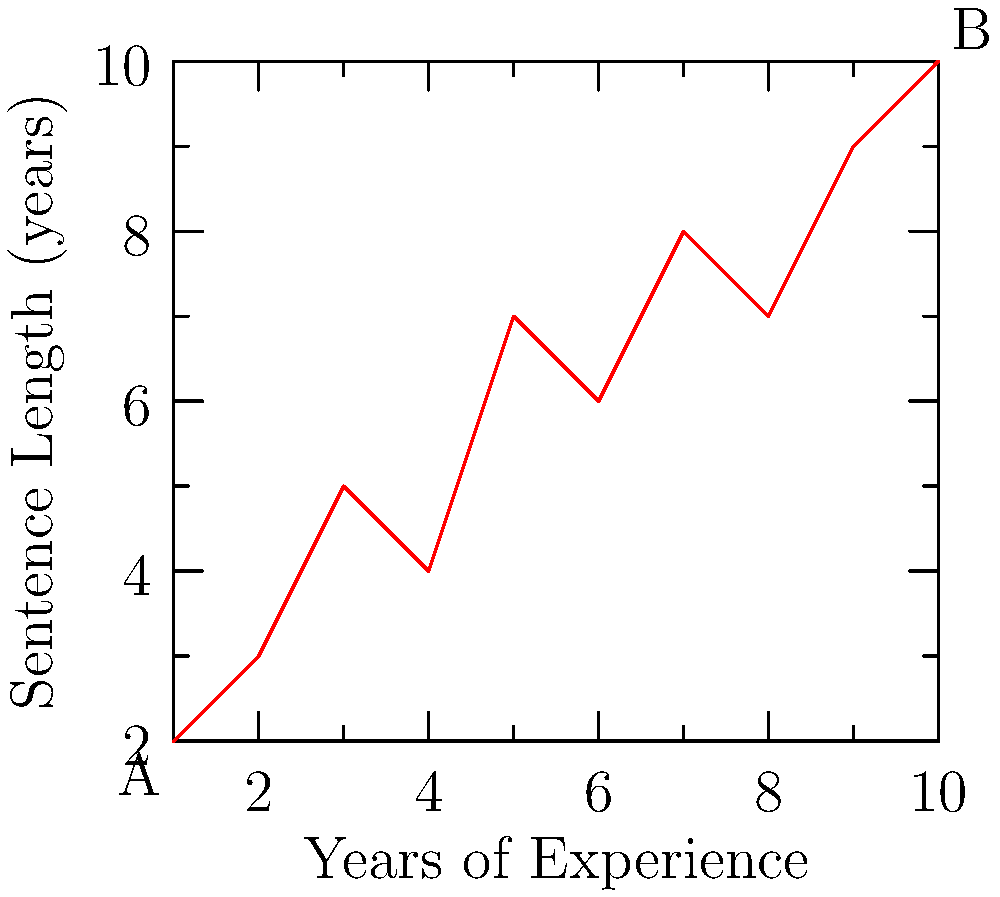Examining the scatter plot of sentencing data, which shows the relationship between a judge's years of experience (x-axis) and the length of sentences given (y-axis), what pattern can be observed? How might this trend impact the principle of consistency in sentencing? To analyze the pattern in the sentencing data:

1. Observe the overall trend: As we move from left to right (increasing years of experience), there is a general upward movement in the data points.

2. Calculate the correlation: The positive slope indicates a positive correlation between years of experience and sentence length.

3. Interpret the relationship: More experienced judges tend to give longer sentences.

4. Consider outliers: There don't appear to be significant outliers that would skew the interpretation.

5. Assess consistency: The trend suggests that sentencing may not be entirely consistent across judges with different levels of experience.

6. Evaluate impact on justice:
   a) Positive aspect: Experienced judges might be better at identifying severe cases.
   b) Negative aspect: It could indicate a drift from sentencing guidelines over time.

7. Consider legal implications: This trend might raise questions about equal treatment under the law, as sentence length appears to depend partly on the judge's experience.

8. Recommend further analysis: Investigate other factors that might explain this trend, such as changes in law or crime patterns over time.
Answer: Positive correlation between judge's experience and sentence length, potentially challenging sentencing consistency. 